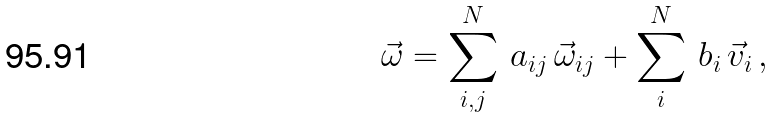Convert formula to latex. <formula><loc_0><loc_0><loc_500><loc_500>\vec { \omega } = \sum _ { i , j } ^ { N } \, a _ { i j } \, \vec { \omega } _ { i j } + \sum _ { i } ^ { N } \, b _ { i } \, \vec { v } _ { i } \, ,</formula> 